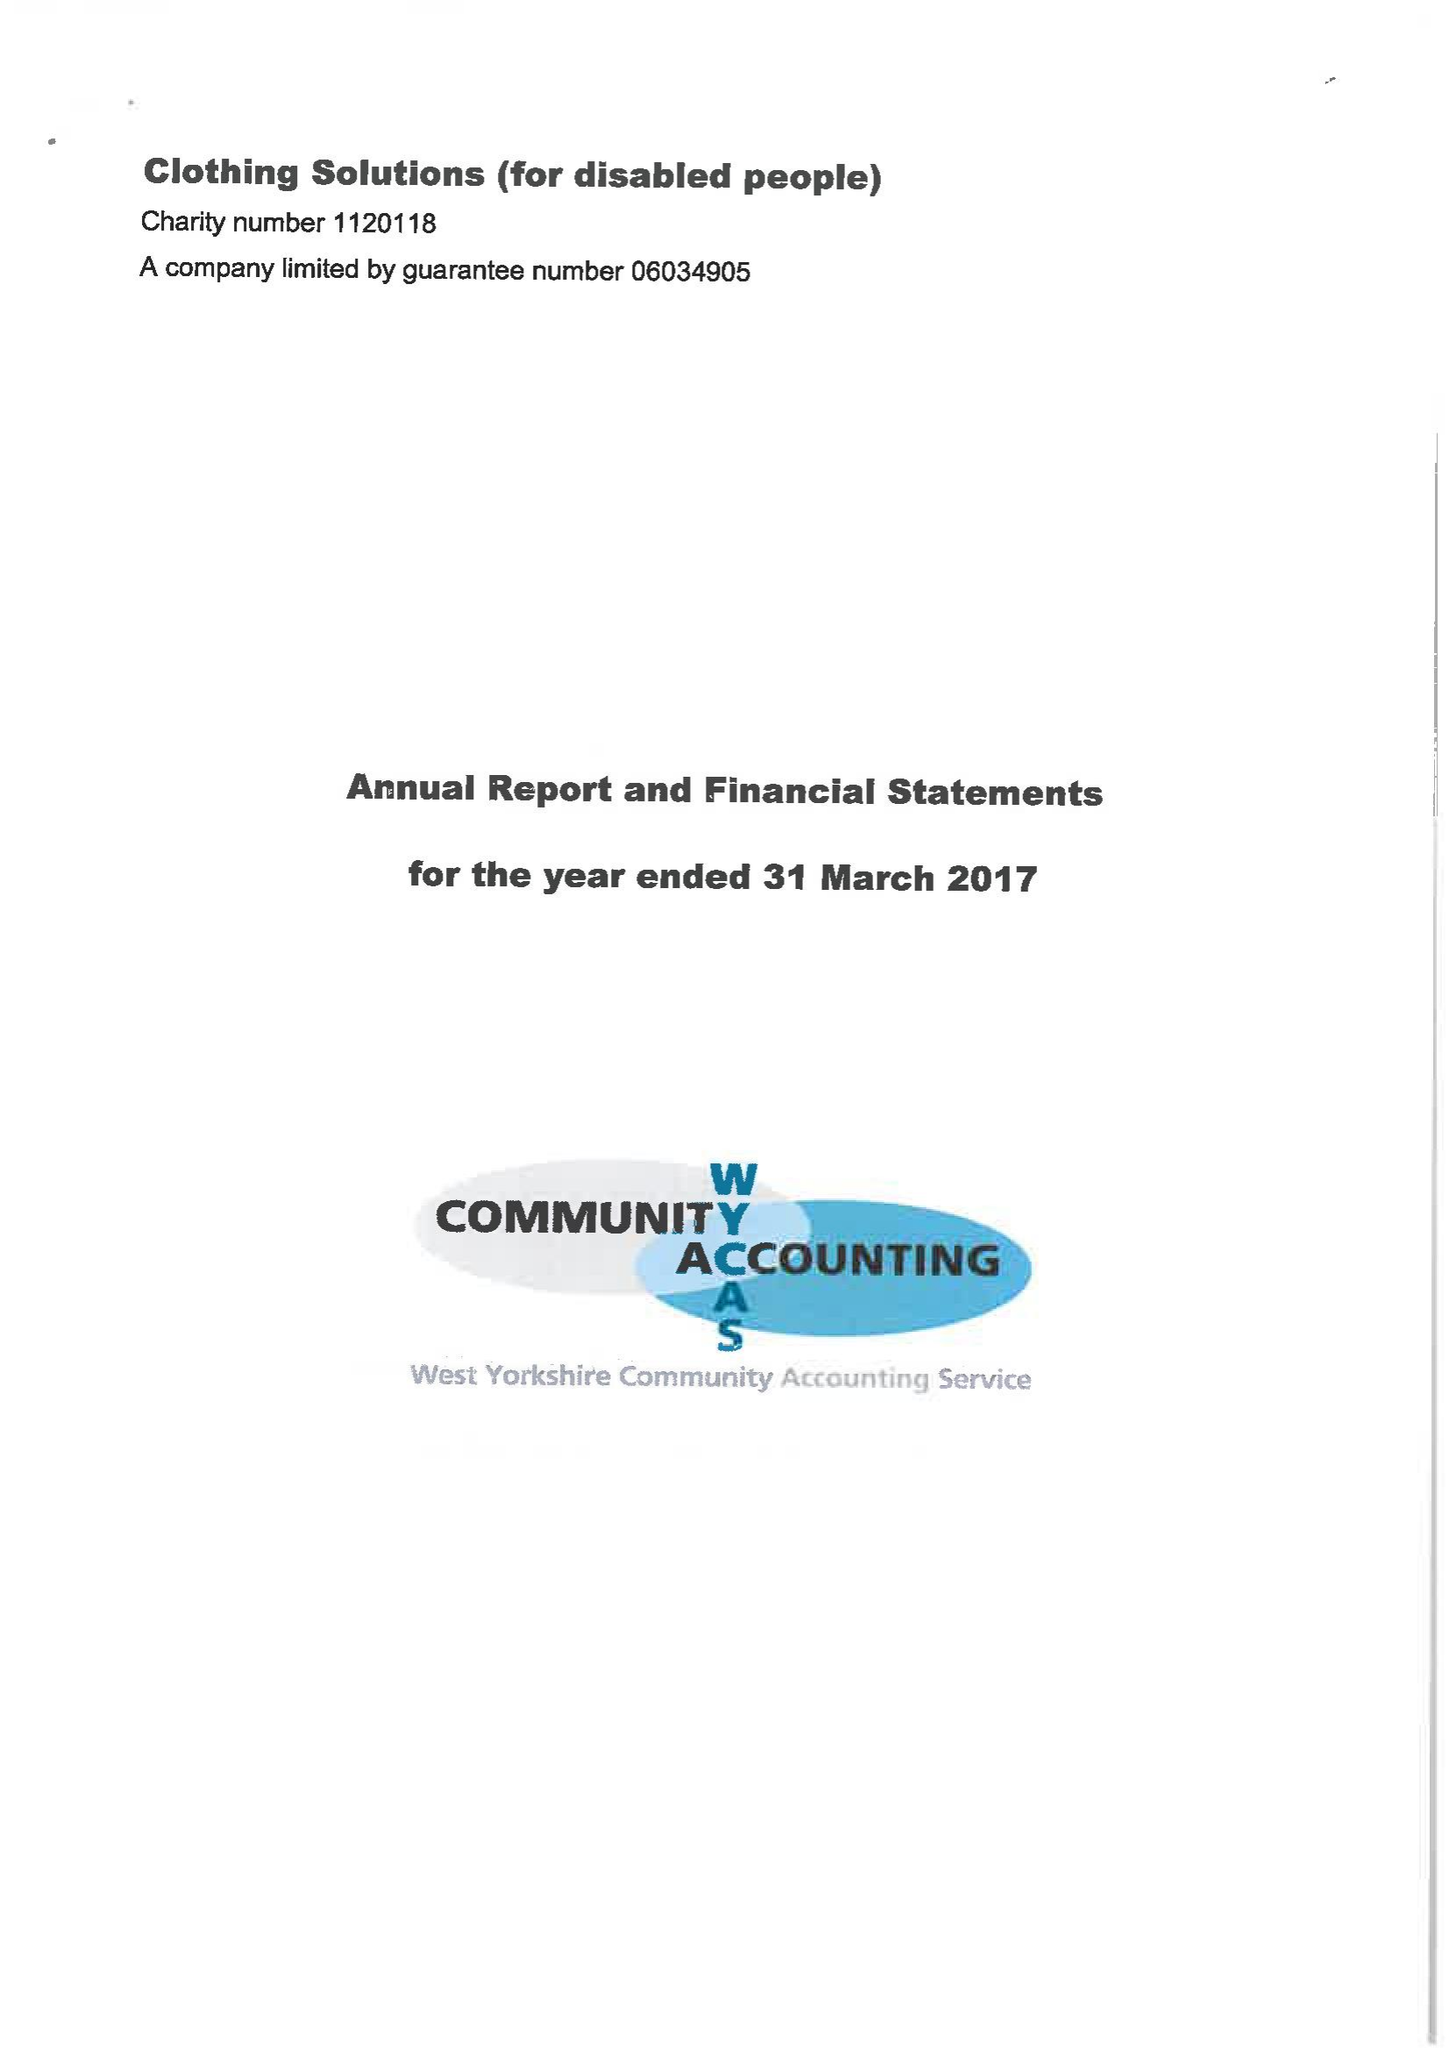What is the value for the address__postcode?
Answer the question using a single word or phrase. None 